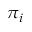Convert formula to latex. <formula><loc_0><loc_0><loc_500><loc_500>\pi _ { i }</formula> 